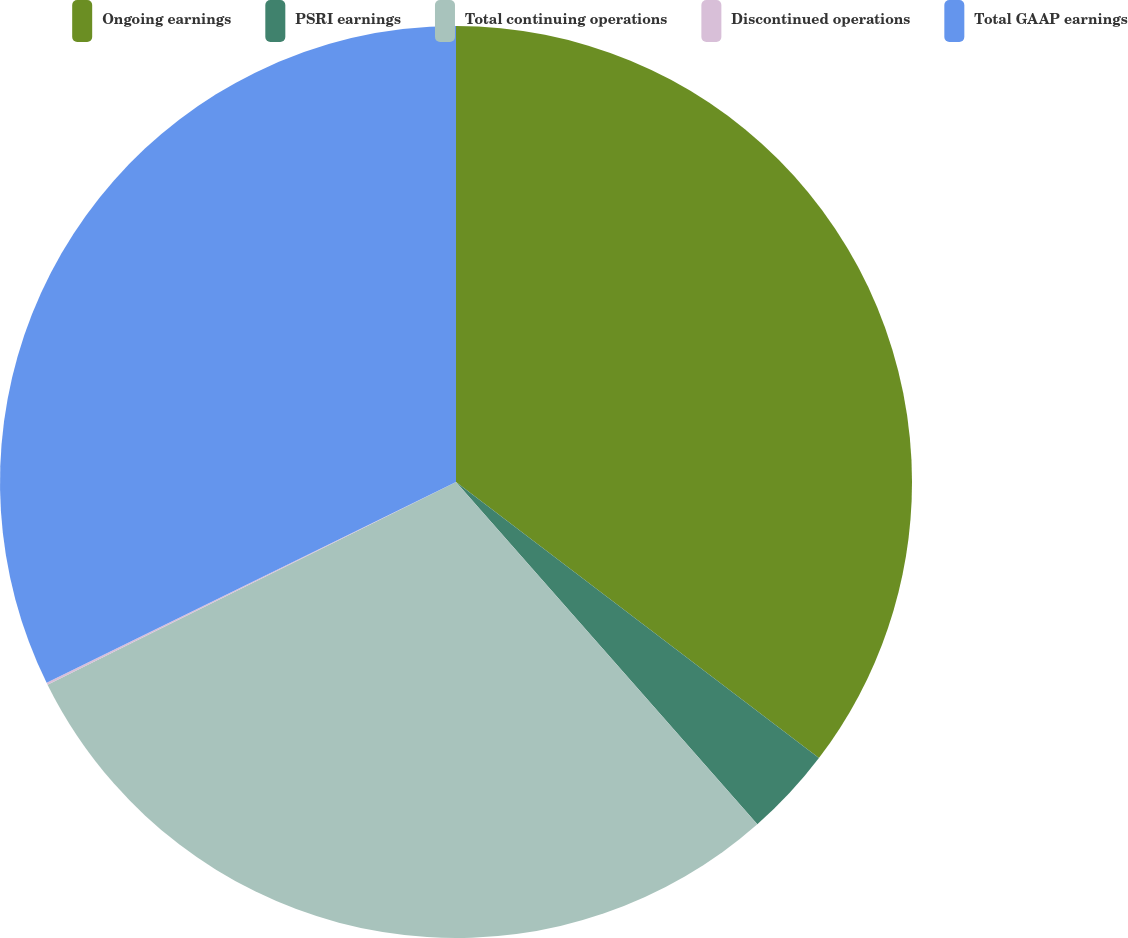Convert chart to OTSL. <chart><loc_0><loc_0><loc_500><loc_500><pie_chart><fcel>Ongoing earnings<fcel>PSRI earnings<fcel>Total continuing operations<fcel>Discontinued operations<fcel>Total GAAP earnings<nl><fcel>35.35%<fcel>3.16%<fcel>29.16%<fcel>0.07%<fcel>32.26%<nl></chart> 